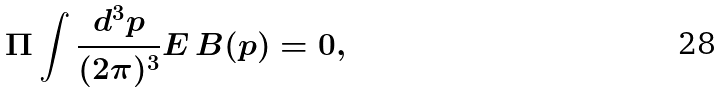<formula> <loc_0><loc_0><loc_500><loc_500>\Pi \int \frac { d ^ { 3 } p } { ( 2 \pi ) ^ { 3 } } E \, B ( p ) = 0 ,</formula> 